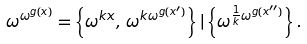<formula> <loc_0><loc_0><loc_500><loc_500>\omega ^ { \omega ^ { g ( x ) } } = \left \{ \omega ^ { k x } , \, \omega ^ { k \omega ^ { g ( x ^ { \prime } ) } } \right \} | \left \{ \omega ^ { \frac { 1 } { k } \omega ^ { g ( x ^ { \prime \prime } ) } } \right \} .</formula> 